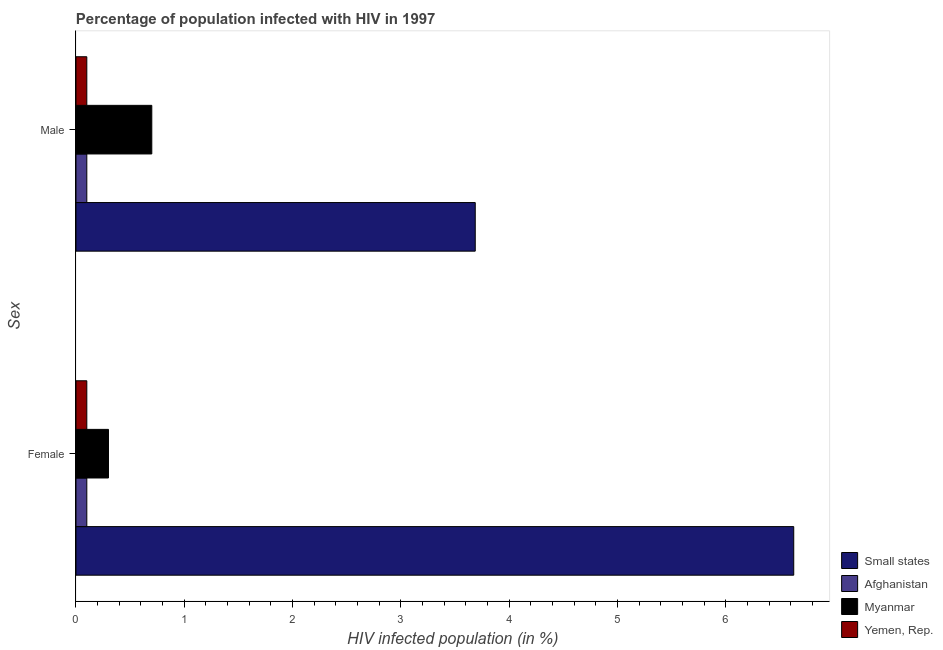How many different coloured bars are there?
Your answer should be very brief. 4. What is the percentage of females who are infected with hiv in Myanmar?
Give a very brief answer. 0.3. Across all countries, what is the maximum percentage of males who are infected with hiv?
Provide a short and direct response. 3.69. Across all countries, what is the minimum percentage of females who are infected with hiv?
Provide a short and direct response. 0.1. In which country was the percentage of females who are infected with hiv maximum?
Offer a terse response. Small states. In which country was the percentage of females who are infected with hiv minimum?
Ensure brevity in your answer.  Afghanistan. What is the total percentage of females who are infected with hiv in the graph?
Your response must be concise. 7.13. What is the difference between the percentage of males who are infected with hiv in Small states and that in Myanmar?
Ensure brevity in your answer.  2.99. What is the difference between the percentage of males who are infected with hiv in Afghanistan and the percentage of females who are infected with hiv in Myanmar?
Keep it short and to the point. -0.2. What is the average percentage of females who are infected with hiv per country?
Provide a short and direct response. 1.78. In how many countries, is the percentage of males who are infected with hiv greater than 5.4 %?
Your response must be concise. 0. What is the ratio of the percentage of males who are infected with hiv in Afghanistan to that in Myanmar?
Provide a succinct answer. 0.14. Is the percentage of females who are infected with hiv in Afghanistan less than that in Myanmar?
Provide a succinct answer. Yes. What does the 3rd bar from the top in Female represents?
Provide a succinct answer. Afghanistan. What does the 3rd bar from the bottom in Male represents?
Offer a terse response. Myanmar. What is the difference between two consecutive major ticks on the X-axis?
Ensure brevity in your answer.  1. Are the values on the major ticks of X-axis written in scientific E-notation?
Your answer should be very brief. No. Does the graph contain any zero values?
Offer a terse response. No. Where does the legend appear in the graph?
Your response must be concise. Bottom right. What is the title of the graph?
Offer a terse response. Percentage of population infected with HIV in 1997. What is the label or title of the X-axis?
Offer a terse response. HIV infected population (in %). What is the label or title of the Y-axis?
Give a very brief answer. Sex. What is the HIV infected population (in %) of Small states in Female?
Ensure brevity in your answer.  6.63. What is the HIV infected population (in %) of Small states in Male?
Make the answer very short. 3.69. What is the HIV infected population (in %) of Afghanistan in Male?
Offer a terse response. 0.1. What is the HIV infected population (in %) of Yemen, Rep. in Male?
Ensure brevity in your answer.  0.1. Across all Sex, what is the maximum HIV infected population (in %) of Small states?
Provide a succinct answer. 6.63. Across all Sex, what is the maximum HIV infected population (in %) of Afghanistan?
Give a very brief answer. 0.1. Across all Sex, what is the maximum HIV infected population (in %) of Myanmar?
Provide a succinct answer. 0.7. Across all Sex, what is the minimum HIV infected population (in %) of Small states?
Offer a very short reply. 3.69. Across all Sex, what is the minimum HIV infected population (in %) of Afghanistan?
Ensure brevity in your answer.  0.1. Across all Sex, what is the minimum HIV infected population (in %) of Myanmar?
Give a very brief answer. 0.3. Across all Sex, what is the minimum HIV infected population (in %) in Yemen, Rep.?
Give a very brief answer. 0.1. What is the total HIV infected population (in %) of Small states in the graph?
Provide a short and direct response. 10.31. What is the total HIV infected population (in %) in Myanmar in the graph?
Provide a succinct answer. 1. What is the difference between the HIV infected population (in %) in Small states in Female and that in Male?
Keep it short and to the point. 2.94. What is the difference between the HIV infected population (in %) in Small states in Female and the HIV infected population (in %) in Afghanistan in Male?
Offer a very short reply. 6.53. What is the difference between the HIV infected population (in %) in Small states in Female and the HIV infected population (in %) in Myanmar in Male?
Keep it short and to the point. 5.93. What is the difference between the HIV infected population (in %) of Small states in Female and the HIV infected population (in %) of Yemen, Rep. in Male?
Keep it short and to the point. 6.53. What is the difference between the HIV infected population (in %) in Afghanistan in Female and the HIV infected population (in %) in Yemen, Rep. in Male?
Provide a succinct answer. 0. What is the difference between the HIV infected population (in %) of Myanmar in Female and the HIV infected population (in %) of Yemen, Rep. in Male?
Provide a short and direct response. 0.2. What is the average HIV infected population (in %) of Small states per Sex?
Ensure brevity in your answer.  5.16. What is the average HIV infected population (in %) in Yemen, Rep. per Sex?
Ensure brevity in your answer.  0.1. What is the difference between the HIV infected population (in %) of Small states and HIV infected population (in %) of Afghanistan in Female?
Give a very brief answer. 6.53. What is the difference between the HIV infected population (in %) in Small states and HIV infected population (in %) in Myanmar in Female?
Ensure brevity in your answer.  6.33. What is the difference between the HIV infected population (in %) of Small states and HIV infected population (in %) of Yemen, Rep. in Female?
Your response must be concise. 6.53. What is the difference between the HIV infected population (in %) of Myanmar and HIV infected population (in %) of Yemen, Rep. in Female?
Offer a terse response. 0.2. What is the difference between the HIV infected population (in %) in Small states and HIV infected population (in %) in Afghanistan in Male?
Provide a succinct answer. 3.59. What is the difference between the HIV infected population (in %) of Small states and HIV infected population (in %) of Myanmar in Male?
Your answer should be compact. 2.99. What is the difference between the HIV infected population (in %) in Small states and HIV infected population (in %) in Yemen, Rep. in Male?
Ensure brevity in your answer.  3.59. What is the ratio of the HIV infected population (in %) of Small states in Female to that in Male?
Ensure brevity in your answer.  1.8. What is the ratio of the HIV infected population (in %) in Afghanistan in Female to that in Male?
Keep it short and to the point. 1. What is the ratio of the HIV infected population (in %) in Myanmar in Female to that in Male?
Ensure brevity in your answer.  0.43. What is the ratio of the HIV infected population (in %) in Yemen, Rep. in Female to that in Male?
Your answer should be compact. 1. What is the difference between the highest and the second highest HIV infected population (in %) of Small states?
Make the answer very short. 2.94. What is the difference between the highest and the lowest HIV infected population (in %) in Small states?
Offer a terse response. 2.94. What is the difference between the highest and the lowest HIV infected population (in %) of Afghanistan?
Ensure brevity in your answer.  0. What is the difference between the highest and the lowest HIV infected population (in %) of Yemen, Rep.?
Ensure brevity in your answer.  0. 